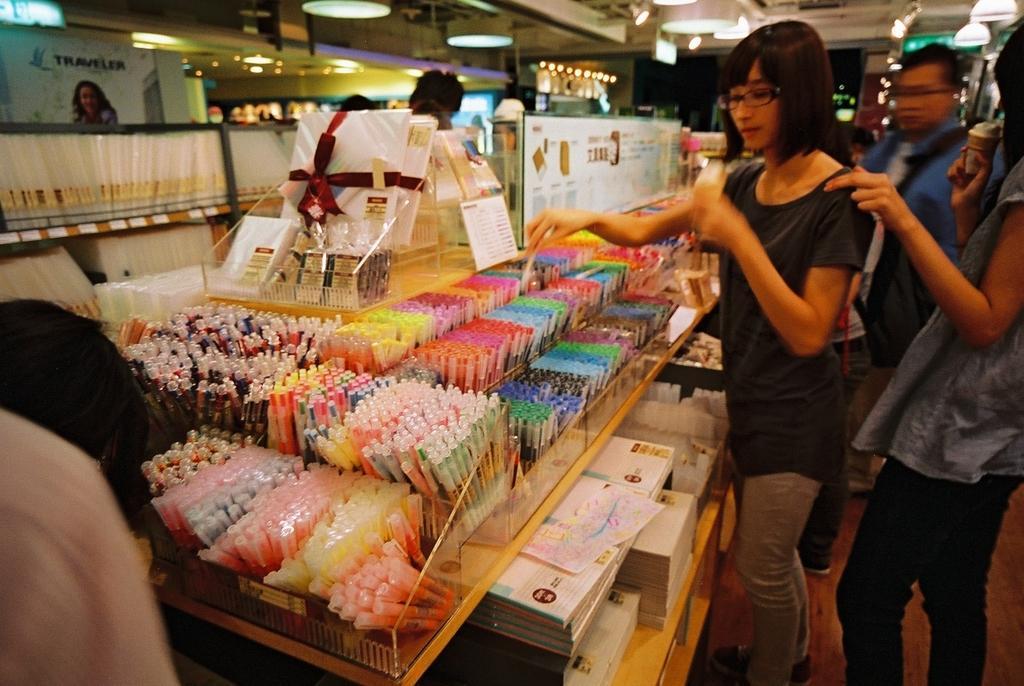Please provide a concise description of this image. This picture describes about group of people, they are standing, in front of them we can see find few pens and books on the table, in the background we can see few lights. 